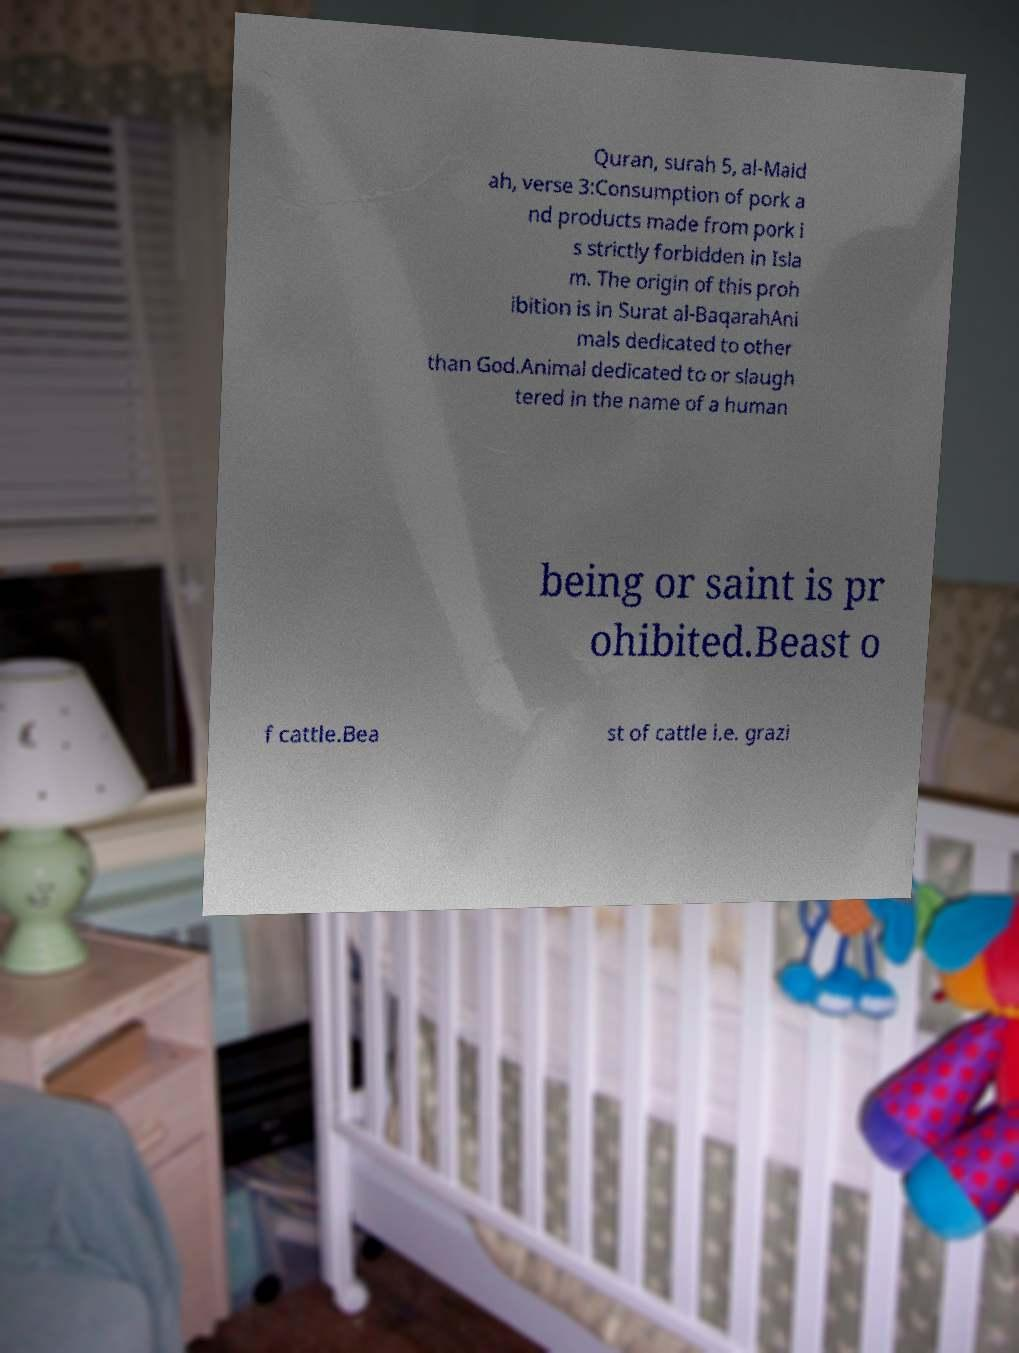Could you assist in decoding the text presented in this image and type it out clearly? Quran, surah 5, al-Maid ah, verse 3:Consumption of pork a nd products made from pork i s strictly forbidden in Isla m. The origin of this proh ibition is in Surat al-BaqarahAni mals dedicated to other than God.Animal dedicated to or slaugh tered in the name of a human being or saint is pr ohibited.Beast o f cattle.Bea st of cattle i.e. grazi 